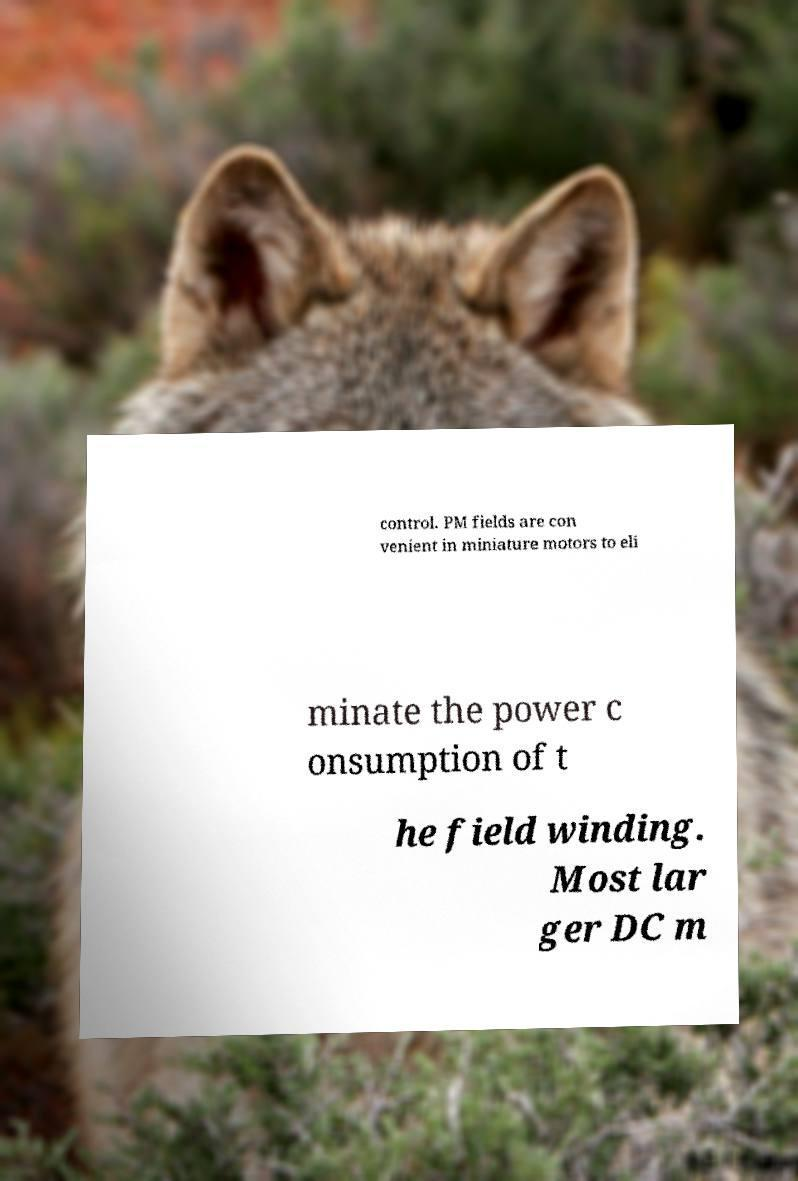Can you read and provide the text displayed in the image?This photo seems to have some interesting text. Can you extract and type it out for me? control. PM fields are con venient in miniature motors to eli minate the power c onsumption of t he field winding. Most lar ger DC m 